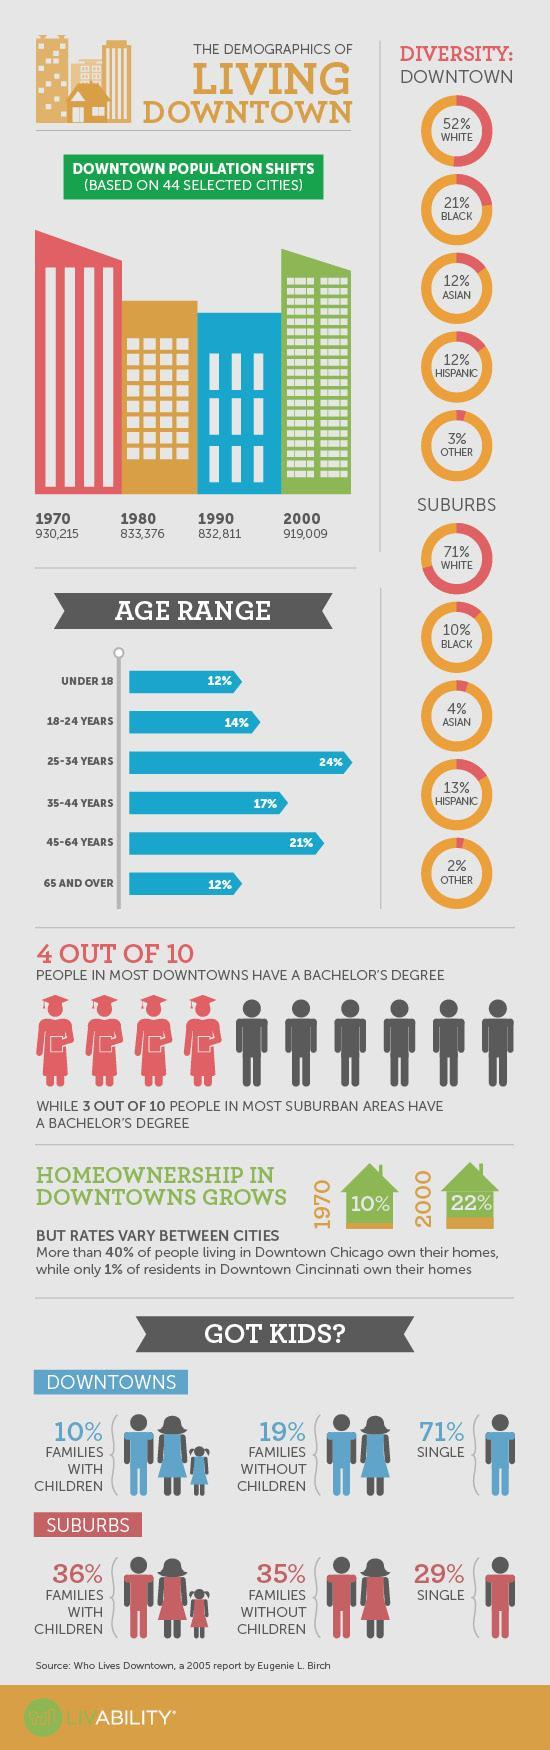What is the percentage of black and white in the Suburbs?
Answer the question with a short phrase. 81% What percentage of downtown have a family with children? 10% What is the percentage of people under 18 and 18-24years, taken together? 26% What is the percentage of black and white in Downtown? 73% What is the percentage of Asians and Hispanics in the Suburbs? 17% What is the difference between the downtown population in 1970 and 2000? 11206 Out of 10, how many people of downtown did not have a bachelor''s degree? 6 Out of 10, how many people of suburban did not have a bachelor''s degree? 7 What is the percentage of Asians and Hispanics in the Downtown? 24% What is the percentage of others in Downtown and Suburbs? 5% What is the percentage of people of age 25-34 and 35-44years, taken together? 41% What percentage of suburbs have a family without children? 35% 